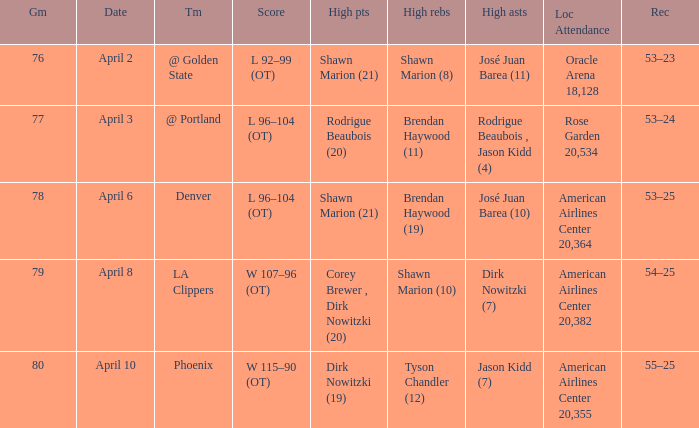What is the record after the Phoenix game? 55–25. 